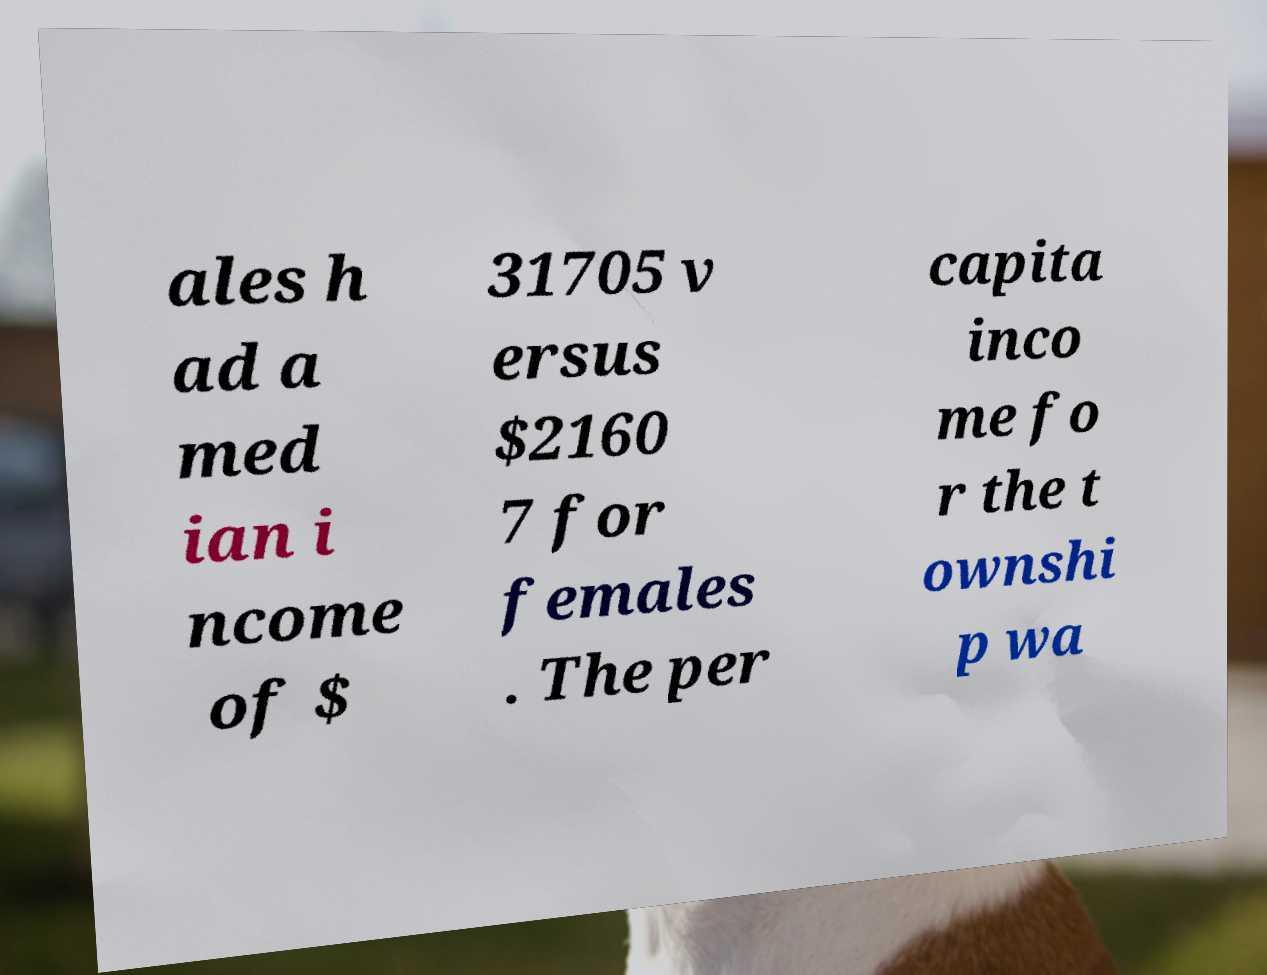Could you extract and type out the text from this image? ales h ad a med ian i ncome of $ 31705 v ersus $2160 7 for females . The per capita inco me fo r the t ownshi p wa 